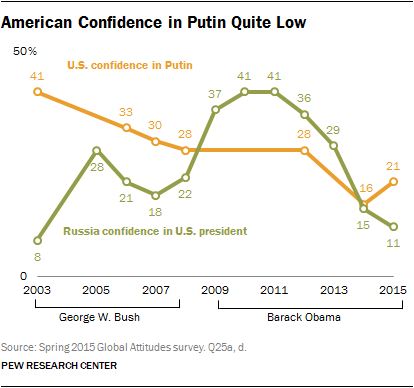Highlight a few significant elements in this photo. The first data in the orange line is 41. In 2014, the green line crossed over the orange line, moving from the top to the bottom. 